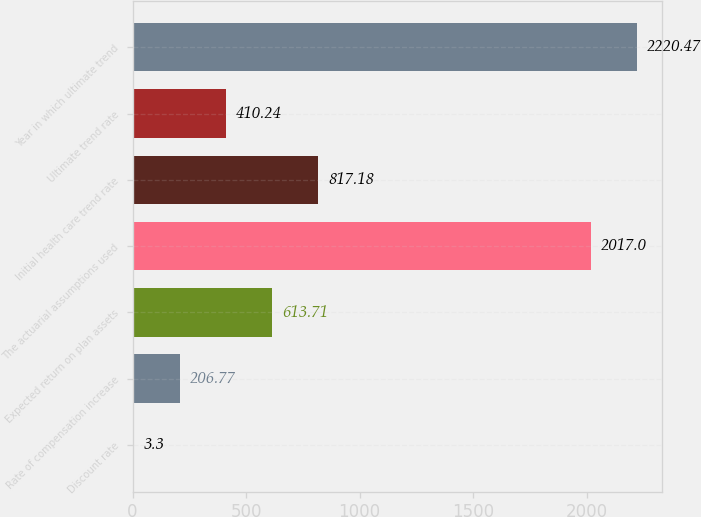<chart> <loc_0><loc_0><loc_500><loc_500><bar_chart><fcel>Discount rate<fcel>Rate of compensation increase<fcel>Expected return on plan assets<fcel>The actuarial assumptions used<fcel>Initial health care trend rate<fcel>Ultimate trend rate<fcel>Year in which ultimate trend<nl><fcel>3.3<fcel>206.77<fcel>613.71<fcel>2017<fcel>817.18<fcel>410.24<fcel>2220.47<nl></chart> 